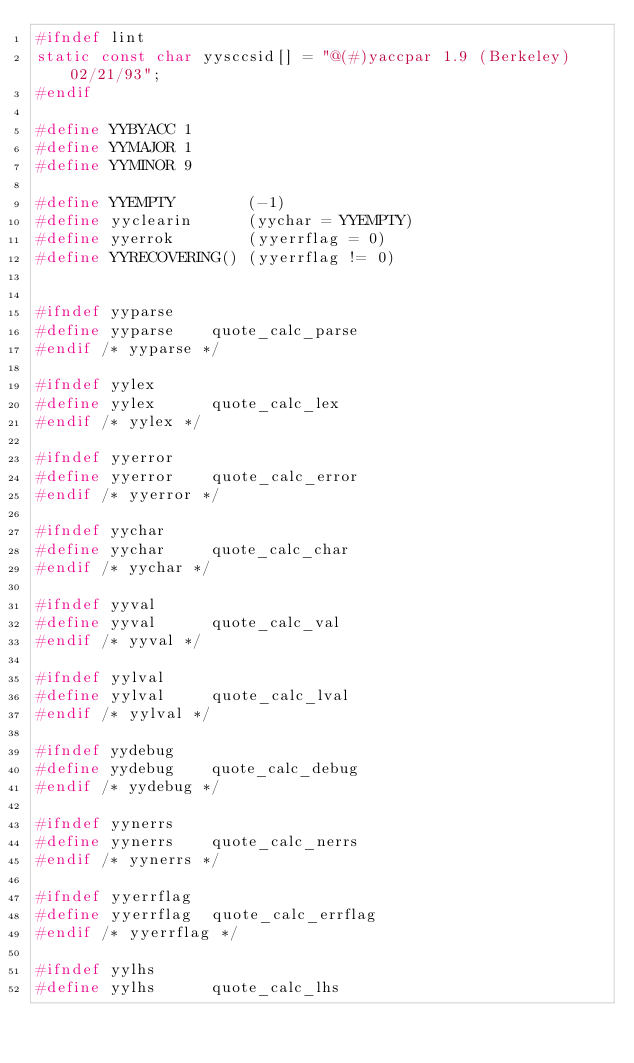<code> <loc_0><loc_0><loc_500><loc_500><_C_>#ifndef lint
static const char yysccsid[] = "@(#)yaccpar	1.9 (Berkeley) 02/21/93";
#endif

#define YYBYACC 1
#define YYMAJOR 1
#define YYMINOR 9

#define YYEMPTY        (-1)
#define yyclearin      (yychar = YYEMPTY)
#define yyerrok        (yyerrflag = 0)
#define YYRECOVERING() (yyerrflag != 0)


#ifndef yyparse
#define yyparse    quote_calc_parse
#endif /* yyparse */

#ifndef yylex
#define yylex      quote_calc_lex
#endif /* yylex */

#ifndef yyerror
#define yyerror    quote_calc_error
#endif /* yyerror */

#ifndef yychar
#define yychar     quote_calc_char
#endif /* yychar */

#ifndef yyval
#define yyval      quote_calc_val
#endif /* yyval */

#ifndef yylval
#define yylval     quote_calc_lval
#endif /* yylval */

#ifndef yydebug
#define yydebug    quote_calc_debug
#endif /* yydebug */

#ifndef yynerrs
#define yynerrs    quote_calc_nerrs
#endif /* yynerrs */

#ifndef yyerrflag
#define yyerrflag  quote_calc_errflag
#endif /* yyerrflag */

#ifndef yylhs
#define yylhs      quote_calc_lhs</code> 